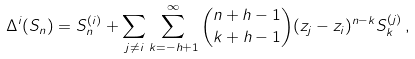<formula> <loc_0><loc_0><loc_500><loc_500>\Delta ^ { i } ( S _ { n } ) = S _ { n } ^ { ( i ) } + \sum _ { j \neq i } \sum _ { k = - h + 1 } ^ { \infty } { n + h - 1 \choose k + h - 1 } ( z _ { j } - z _ { i } ) ^ { n - k } S _ { k } ^ { ( j ) } \, ,</formula> 